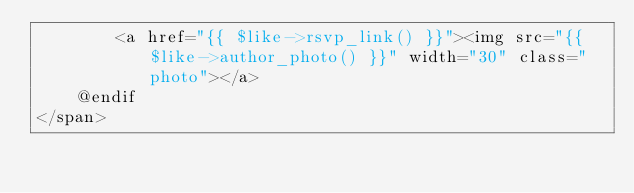<code> <loc_0><loc_0><loc_500><loc_500><_PHP_>        <a href="{{ $like->rsvp_link() }}"><img src="{{ $like->author_photo() }}" width="30" class="photo"></a>
    @endif
</span>
</code> 